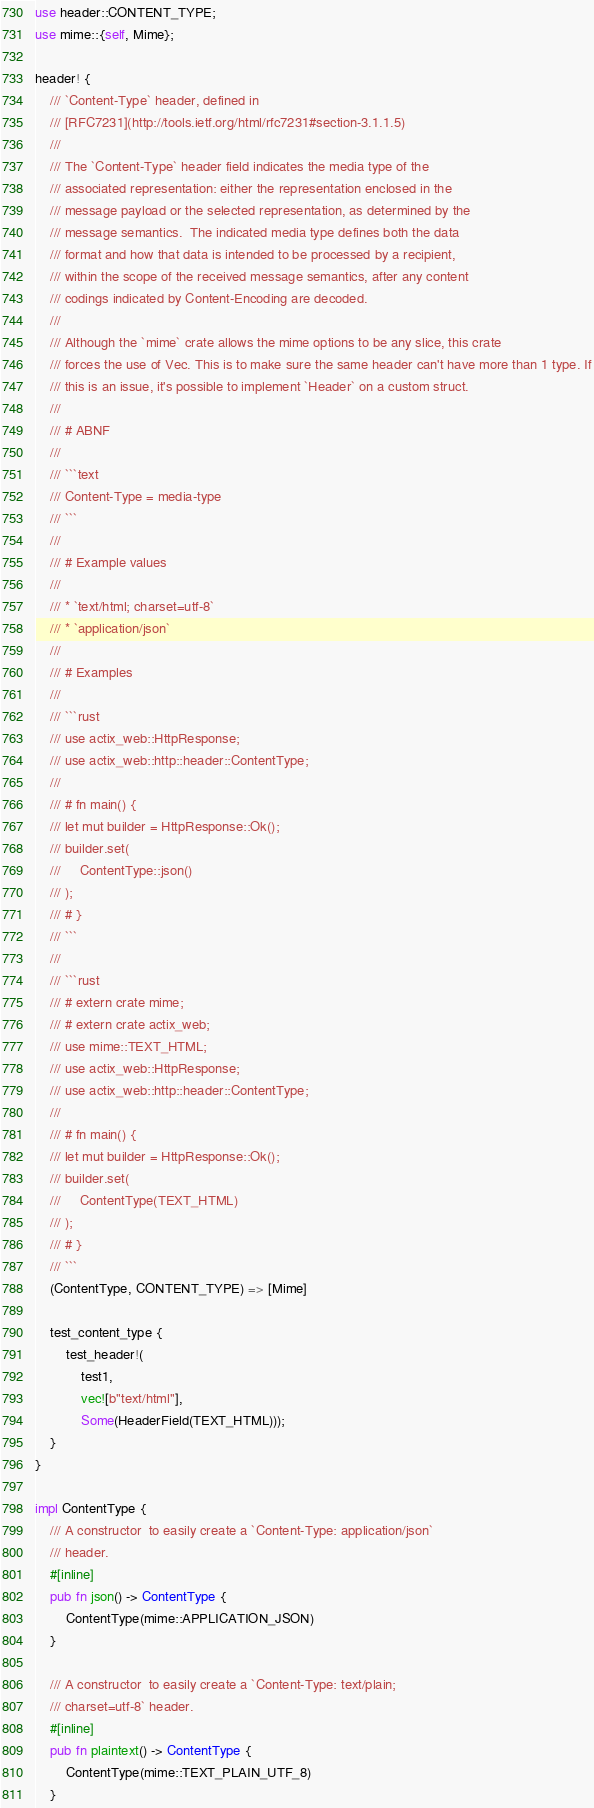Convert code to text. <code><loc_0><loc_0><loc_500><loc_500><_Rust_>use header::CONTENT_TYPE;
use mime::{self, Mime};

header! {
    /// `Content-Type` header, defined in
    /// [RFC7231](http://tools.ietf.org/html/rfc7231#section-3.1.1.5)
    ///
    /// The `Content-Type` header field indicates the media type of the
    /// associated representation: either the representation enclosed in the
    /// message payload or the selected representation, as determined by the
    /// message semantics.  The indicated media type defines both the data
    /// format and how that data is intended to be processed by a recipient,
    /// within the scope of the received message semantics, after any content
    /// codings indicated by Content-Encoding are decoded.
    ///
    /// Although the `mime` crate allows the mime options to be any slice, this crate
    /// forces the use of Vec. This is to make sure the same header can't have more than 1 type. If
    /// this is an issue, it's possible to implement `Header` on a custom struct.
    ///
    /// # ABNF
    ///
    /// ```text
    /// Content-Type = media-type
    /// ```
    ///
    /// # Example values
    ///
    /// * `text/html; charset=utf-8`
    /// * `application/json`
    ///
    /// # Examples
    ///
    /// ```rust
    /// use actix_web::HttpResponse;
    /// use actix_web::http::header::ContentType;
    ///
    /// # fn main() {
    /// let mut builder = HttpResponse::Ok();
    /// builder.set(
    ///     ContentType::json()
    /// );
    /// # }
    /// ```
    ///
    /// ```rust
    /// # extern crate mime;
    /// # extern crate actix_web;
    /// use mime::TEXT_HTML;
    /// use actix_web::HttpResponse;
    /// use actix_web::http::header::ContentType;
    ///
    /// # fn main() {
    /// let mut builder = HttpResponse::Ok();
    /// builder.set(
    ///     ContentType(TEXT_HTML)
    /// );
    /// # }
    /// ```
    (ContentType, CONTENT_TYPE) => [Mime]

    test_content_type {
        test_header!(
            test1,
            vec![b"text/html"],
            Some(HeaderField(TEXT_HTML)));
    }
}

impl ContentType {
    /// A constructor  to easily create a `Content-Type: application/json`
    /// header.
    #[inline]
    pub fn json() -> ContentType {
        ContentType(mime::APPLICATION_JSON)
    }

    /// A constructor  to easily create a `Content-Type: text/plain;
    /// charset=utf-8` header.
    #[inline]
    pub fn plaintext() -> ContentType {
        ContentType(mime::TEXT_PLAIN_UTF_8)
    }
</code> 